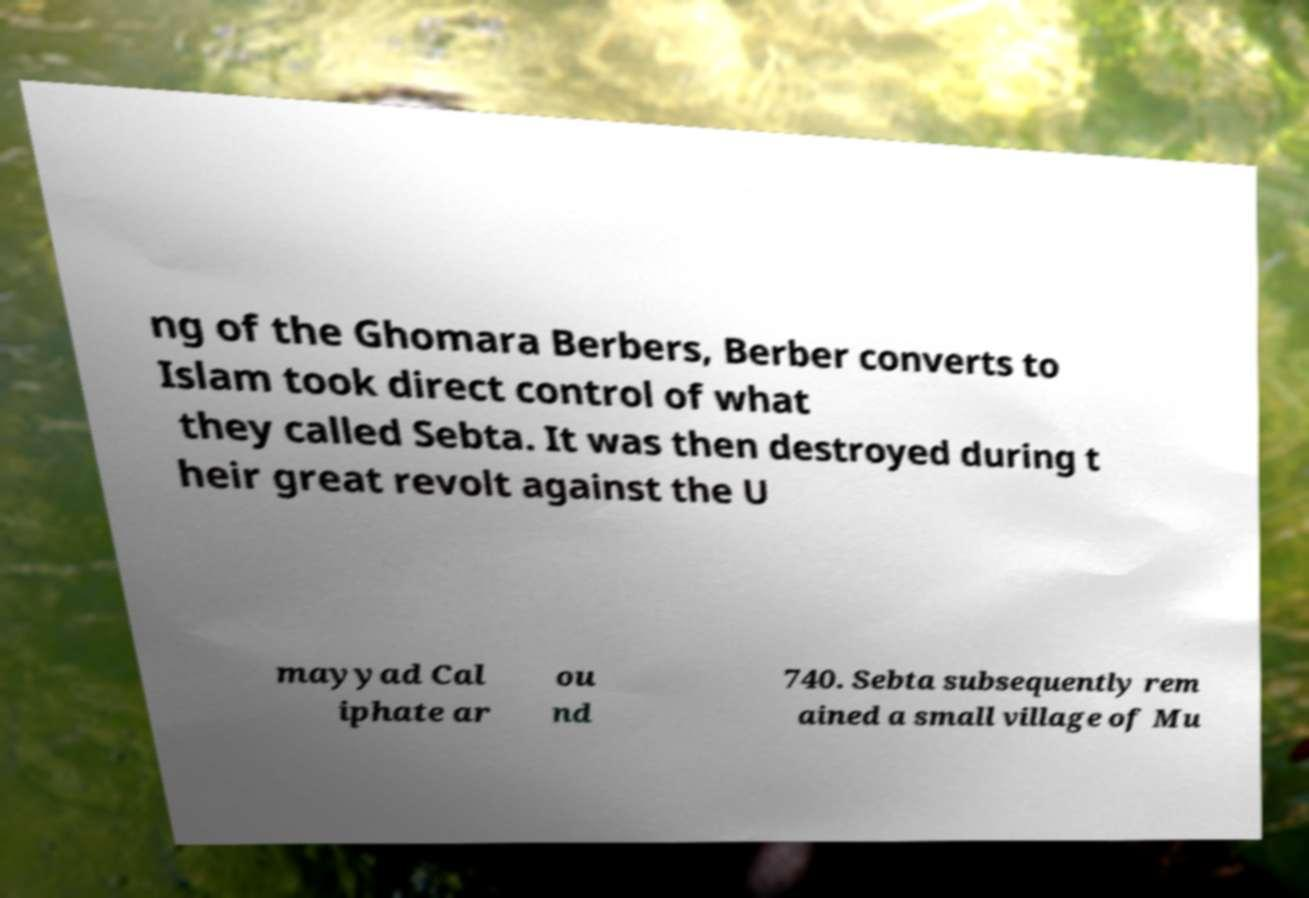What messages or text are displayed in this image? I need them in a readable, typed format. ng of the Ghomara Berbers, Berber converts to Islam took direct control of what they called Sebta. It was then destroyed during t heir great revolt against the U mayyad Cal iphate ar ou nd 740. Sebta subsequently rem ained a small village of Mu 